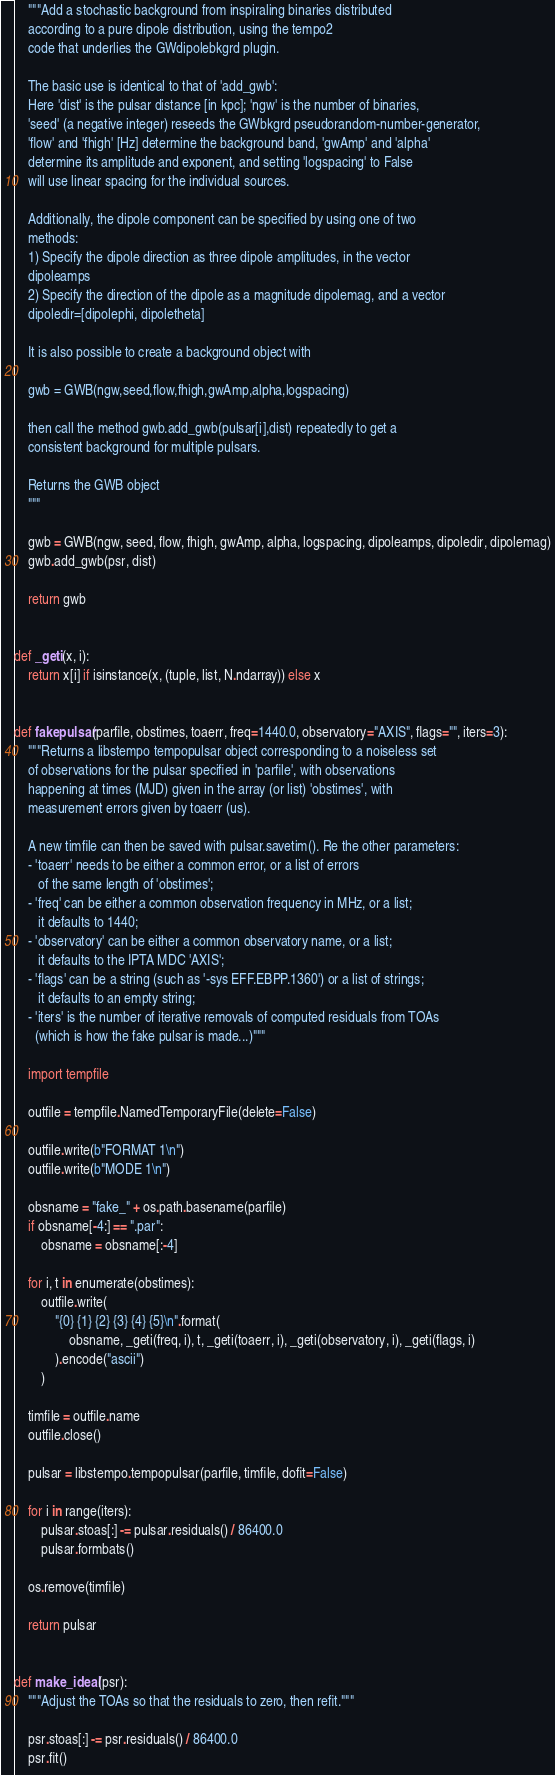<code> <loc_0><loc_0><loc_500><loc_500><_Python_>    """Add a stochastic background from inspiraling binaries distributed
    according to a pure dipole distribution, using the tempo2
    code that underlies the GWdipolebkgrd plugin.

    The basic use is identical to that of 'add_gwb':
    Here 'dist' is the pulsar distance [in kpc]; 'ngw' is the number of binaries,
    'seed' (a negative integer) reseeds the GWbkgrd pseudorandom-number-generator,
    'flow' and 'fhigh' [Hz] determine the background band, 'gwAmp' and 'alpha'
    determine its amplitude and exponent, and setting 'logspacing' to False
    will use linear spacing for the individual sources.

    Additionally, the dipole component can be specified by using one of two
    methods:
    1) Specify the dipole direction as three dipole amplitudes, in the vector
    dipoleamps
    2) Specify the direction of the dipole as a magnitude dipolemag, and a vector
    dipoledir=[dipolephi, dipoletheta]

    It is also possible to create a background object with

    gwb = GWB(ngw,seed,flow,fhigh,gwAmp,alpha,logspacing)

    then call the method gwb.add_gwb(pulsar[i],dist) repeatedly to get a
    consistent background for multiple pulsars.

    Returns the GWB object
    """

    gwb = GWB(ngw, seed, flow, fhigh, gwAmp, alpha, logspacing, dipoleamps, dipoledir, dipolemag)
    gwb.add_gwb(psr, dist)

    return gwb


def _geti(x, i):
    return x[i] if isinstance(x, (tuple, list, N.ndarray)) else x


def fakepulsar(parfile, obstimes, toaerr, freq=1440.0, observatory="AXIS", flags="", iters=3):
    """Returns a libstempo tempopulsar object corresponding to a noiseless set
    of observations for the pulsar specified in 'parfile', with observations
    happening at times (MJD) given in the array (or list) 'obstimes', with
    measurement errors given by toaerr (us).

    A new timfile can then be saved with pulsar.savetim(). Re the other parameters:
    - 'toaerr' needs to be either a common error, or a list of errors
       of the same length of 'obstimes';
    - 'freq' can be either a common observation frequency in MHz, or a list;
       it defaults to 1440;
    - 'observatory' can be either a common observatory name, or a list;
       it defaults to the IPTA MDC 'AXIS';
    - 'flags' can be a string (such as '-sys EFF.EBPP.1360') or a list of strings;
       it defaults to an empty string;
    - 'iters' is the number of iterative removals of computed residuals from TOAs
      (which is how the fake pulsar is made...)"""

    import tempfile

    outfile = tempfile.NamedTemporaryFile(delete=False)

    outfile.write(b"FORMAT 1\n")
    outfile.write(b"MODE 1\n")

    obsname = "fake_" + os.path.basename(parfile)
    if obsname[-4:] == ".par":
        obsname = obsname[:-4]

    for i, t in enumerate(obstimes):
        outfile.write(
            "{0} {1} {2} {3} {4} {5}\n".format(
                obsname, _geti(freq, i), t, _geti(toaerr, i), _geti(observatory, i), _geti(flags, i)
            ).encode("ascii")
        )

    timfile = outfile.name
    outfile.close()

    pulsar = libstempo.tempopulsar(parfile, timfile, dofit=False)

    for i in range(iters):
        pulsar.stoas[:] -= pulsar.residuals() / 86400.0
        pulsar.formbats()

    os.remove(timfile)

    return pulsar


def make_ideal(psr):
    """Adjust the TOAs so that the residuals to zero, then refit."""

    psr.stoas[:] -= psr.residuals() / 86400.0
    psr.fit()

</code> 